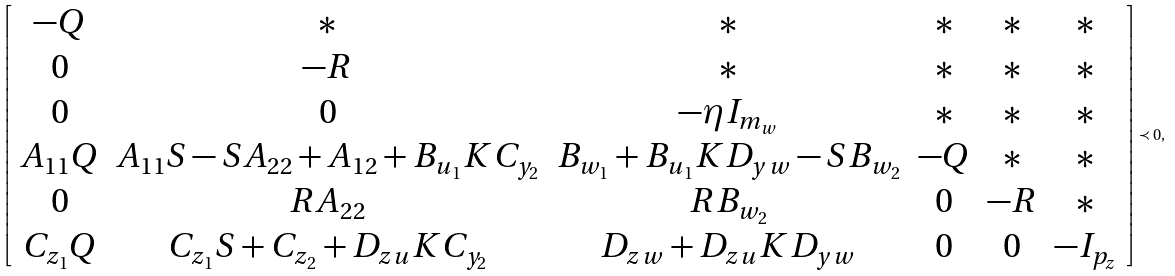<formula> <loc_0><loc_0><loc_500><loc_500>\left [ \begin{array} { c c c c c c } - Q & \ast & \ast & \ast & \ast & \ast \\ 0 & - R & \ast & \ast & \ast & \ast \\ 0 & 0 & - \eta I _ { m _ { w } } & \ast & \ast & \ast \\ A _ { 1 1 } Q & A _ { 1 1 } S - S A _ { 2 2 } + A _ { 1 2 } + B _ { u _ { 1 } } K C _ { y _ { 2 } } & B _ { w _ { 1 } } + B _ { u _ { 1 } } K D _ { y w } - S B _ { w _ { 2 } } & - Q & \ast & \ast \\ 0 & R A _ { 2 2 } & R B _ { w _ { 2 } } & 0 & - R & \ast \\ C _ { z _ { 1 } } Q & C _ { z _ { 1 } } S + C _ { z _ { 2 } } + D _ { z u } K C _ { y _ { 2 } } & D _ { z w } + D _ { z u } K D _ { y w } & 0 & 0 & - I _ { p _ { z } } \end{array} \right ] \prec 0 ,</formula> 